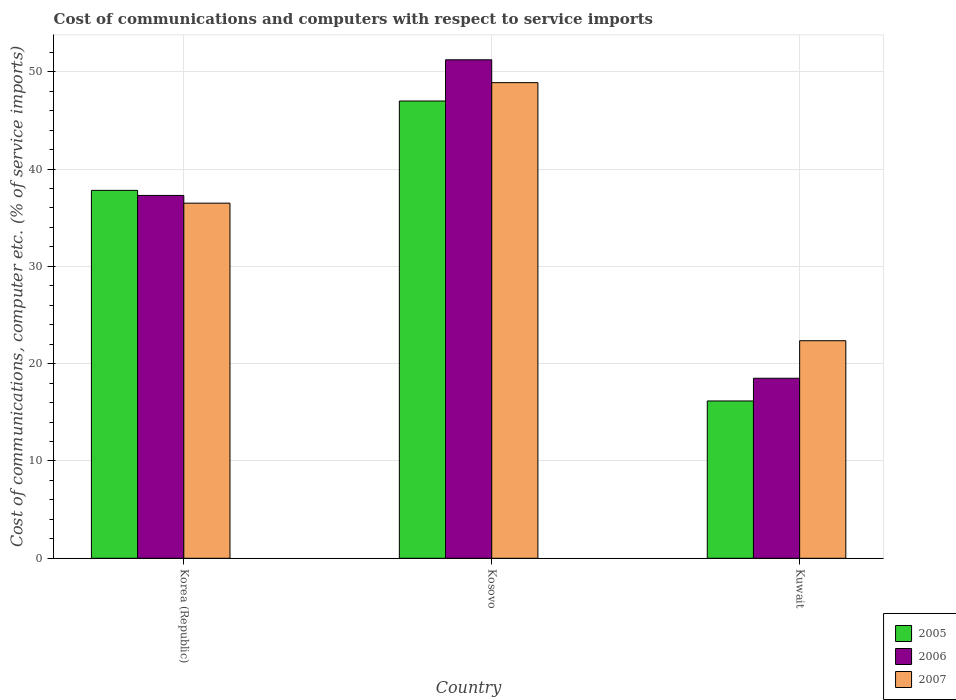How many groups of bars are there?
Ensure brevity in your answer.  3. Are the number of bars per tick equal to the number of legend labels?
Your response must be concise. Yes. How many bars are there on the 2nd tick from the right?
Your answer should be very brief. 3. What is the label of the 2nd group of bars from the left?
Provide a short and direct response. Kosovo. What is the cost of communications and computers in 2006 in Kuwait?
Provide a succinct answer. 18.5. Across all countries, what is the maximum cost of communications and computers in 2005?
Provide a succinct answer. 46.99. Across all countries, what is the minimum cost of communications and computers in 2007?
Make the answer very short. 22.36. In which country was the cost of communications and computers in 2005 maximum?
Give a very brief answer. Kosovo. In which country was the cost of communications and computers in 2006 minimum?
Offer a terse response. Kuwait. What is the total cost of communications and computers in 2005 in the graph?
Offer a terse response. 100.97. What is the difference between the cost of communications and computers in 2007 in Kosovo and that in Kuwait?
Your response must be concise. 26.52. What is the difference between the cost of communications and computers in 2007 in Kuwait and the cost of communications and computers in 2006 in Korea (Republic)?
Your response must be concise. -14.93. What is the average cost of communications and computers in 2006 per country?
Provide a succinct answer. 35.67. What is the difference between the cost of communications and computers of/in 2006 and cost of communications and computers of/in 2007 in Kuwait?
Offer a very short reply. -3.86. In how many countries, is the cost of communications and computers in 2006 greater than 24 %?
Your response must be concise. 2. What is the ratio of the cost of communications and computers in 2005 in Kosovo to that in Kuwait?
Give a very brief answer. 2.91. What is the difference between the highest and the second highest cost of communications and computers in 2005?
Offer a terse response. -21.64. What is the difference between the highest and the lowest cost of communications and computers in 2007?
Your answer should be compact. 26.52. In how many countries, is the cost of communications and computers in 2007 greater than the average cost of communications and computers in 2007 taken over all countries?
Your answer should be compact. 2. What does the 1st bar from the left in Kuwait represents?
Your answer should be very brief. 2005. What does the 3rd bar from the right in Kuwait represents?
Offer a terse response. 2005. Are all the bars in the graph horizontal?
Make the answer very short. No. How many countries are there in the graph?
Keep it short and to the point. 3. What is the difference between two consecutive major ticks on the Y-axis?
Keep it short and to the point. 10. Does the graph contain grids?
Make the answer very short. Yes. Where does the legend appear in the graph?
Make the answer very short. Bottom right. What is the title of the graph?
Provide a succinct answer. Cost of communications and computers with respect to service imports. What is the label or title of the X-axis?
Ensure brevity in your answer.  Country. What is the label or title of the Y-axis?
Offer a terse response. Cost of communications, computer etc. (% of service imports). What is the Cost of communications, computer etc. (% of service imports) in 2005 in Korea (Republic)?
Provide a short and direct response. 37.81. What is the Cost of communications, computer etc. (% of service imports) of 2006 in Korea (Republic)?
Your response must be concise. 37.29. What is the Cost of communications, computer etc. (% of service imports) of 2007 in Korea (Republic)?
Ensure brevity in your answer.  36.49. What is the Cost of communications, computer etc. (% of service imports) in 2005 in Kosovo?
Keep it short and to the point. 46.99. What is the Cost of communications, computer etc. (% of service imports) of 2006 in Kosovo?
Your answer should be compact. 51.23. What is the Cost of communications, computer etc. (% of service imports) in 2007 in Kosovo?
Offer a very short reply. 48.88. What is the Cost of communications, computer etc. (% of service imports) of 2005 in Kuwait?
Offer a terse response. 16.17. What is the Cost of communications, computer etc. (% of service imports) of 2006 in Kuwait?
Ensure brevity in your answer.  18.5. What is the Cost of communications, computer etc. (% of service imports) of 2007 in Kuwait?
Your answer should be compact. 22.36. Across all countries, what is the maximum Cost of communications, computer etc. (% of service imports) in 2005?
Make the answer very short. 46.99. Across all countries, what is the maximum Cost of communications, computer etc. (% of service imports) in 2006?
Provide a short and direct response. 51.23. Across all countries, what is the maximum Cost of communications, computer etc. (% of service imports) in 2007?
Offer a terse response. 48.88. Across all countries, what is the minimum Cost of communications, computer etc. (% of service imports) of 2005?
Give a very brief answer. 16.17. Across all countries, what is the minimum Cost of communications, computer etc. (% of service imports) of 2006?
Give a very brief answer. 18.5. Across all countries, what is the minimum Cost of communications, computer etc. (% of service imports) of 2007?
Provide a succinct answer. 22.36. What is the total Cost of communications, computer etc. (% of service imports) of 2005 in the graph?
Keep it short and to the point. 100.97. What is the total Cost of communications, computer etc. (% of service imports) of 2006 in the graph?
Keep it short and to the point. 107.02. What is the total Cost of communications, computer etc. (% of service imports) of 2007 in the graph?
Provide a succinct answer. 107.73. What is the difference between the Cost of communications, computer etc. (% of service imports) in 2005 in Korea (Republic) and that in Kosovo?
Your answer should be very brief. -9.18. What is the difference between the Cost of communications, computer etc. (% of service imports) of 2006 in Korea (Republic) and that in Kosovo?
Your answer should be very brief. -13.94. What is the difference between the Cost of communications, computer etc. (% of service imports) of 2007 in Korea (Republic) and that in Kosovo?
Make the answer very short. -12.39. What is the difference between the Cost of communications, computer etc. (% of service imports) of 2005 in Korea (Republic) and that in Kuwait?
Your answer should be compact. 21.64. What is the difference between the Cost of communications, computer etc. (% of service imports) in 2006 in Korea (Republic) and that in Kuwait?
Provide a short and direct response. 18.79. What is the difference between the Cost of communications, computer etc. (% of service imports) of 2007 in Korea (Republic) and that in Kuwait?
Your answer should be very brief. 14.14. What is the difference between the Cost of communications, computer etc. (% of service imports) of 2005 in Kosovo and that in Kuwait?
Give a very brief answer. 30.82. What is the difference between the Cost of communications, computer etc. (% of service imports) in 2006 in Kosovo and that in Kuwait?
Keep it short and to the point. 32.73. What is the difference between the Cost of communications, computer etc. (% of service imports) of 2007 in Kosovo and that in Kuwait?
Your answer should be very brief. 26.52. What is the difference between the Cost of communications, computer etc. (% of service imports) in 2005 in Korea (Republic) and the Cost of communications, computer etc. (% of service imports) in 2006 in Kosovo?
Offer a terse response. -13.42. What is the difference between the Cost of communications, computer etc. (% of service imports) in 2005 in Korea (Republic) and the Cost of communications, computer etc. (% of service imports) in 2007 in Kosovo?
Ensure brevity in your answer.  -11.07. What is the difference between the Cost of communications, computer etc. (% of service imports) in 2006 in Korea (Republic) and the Cost of communications, computer etc. (% of service imports) in 2007 in Kosovo?
Your response must be concise. -11.59. What is the difference between the Cost of communications, computer etc. (% of service imports) in 2005 in Korea (Republic) and the Cost of communications, computer etc. (% of service imports) in 2006 in Kuwait?
Offer a very short reply. 19.31. What is the difference between the Cost of communications, computer etc. (% of service imports) in 2005 in Korea (Republic) and the Cost of communications, computer etc. (% of service imports) in 2007 in Kuwait?
Give a very brief answer. 15.45. What is the difference between the Cost of communications, computer etc. (% of service imports) of 2006 in Korea (Republic) and the Cost of communications, computer etc. (% of service imports) of 2007 in Kuwait?
Offer a very short reply. 14.93. What is the difference between the Cost of communications, computer etc. (% of service imports) in 2005 in Kosovo and the Cost of communications, computer etc. (% of service imports) in 2006 in Kuwait?
Your answer should be very brief. 28.49. What is the difference between the Cost of communications, computer etc. (% of service imports) in 2005 in Kosovo and the Cost of communications, computer etc. (% of service imports) in 2007 in Kuwait?
Your answer should be very brief. 24.63. What is the difference between the Cost of communications, computer etc. (% of service imports) in 2006 in Kosovo and the Cost of communications, computer etc. (% of service imports) in 2007 in Kuwait?
Give a very brief answer. 28.87. What is the average Cost of communications, computer etc. (% of service imports) in 2005 per country?
Your answer should be very brief. 33.66. What is the average Cost of communications, computer etc. (% of service imports) of 2006 per country?
Ensure brevity in your answer.  35.67. What is the average Cost of communications, computer etc. (% of service imports) in 2007 per country?
Ensure brevity in your answer.  35.91. What is the difference between the Cost of communications, computer etc. (% of service imports) in 2005 and Cost of communications, computer etc. (% of service imports) in 2006 in Korea (Republic)?
Offer a very short reply. 0.52. What is the difference between the Cost of communications, computer etc. (% of service imports) in 2005 and Cost of communications, computer etc. (% of service imports) in 2007 in Korea (Republic)?
Your response must be concise. 1.32. What is the difference between the Cost of communications, computer etc. (% of service imports) in 2006 and Cost of communications, computer etc. (% of service imports) in 2007 in Korea (Republic)?
Ensure brevity in your answer.  0.8. What is the difference between the Cost of communications, computer etc. (% of service imports) of 2005 and Cost of communications, computer etc. (% of service imports) of 2006 in Kosovo?
Offer a very short reply. -4.24. What is the difference between the Cost of communications, computer etc. (% of service imports) in 2005 and Cost of communications, computer etc. (% of service imports) in 2007 in Kosovo?
Provide a short and direct response. -1.89. What is the difference between the Cost of communications, computer etc. (% of service imports) of 2006 and Cost of communications, computer etc. (% of service imports) of 2007 in Kosovo?
Your answer should be very brief. 2.35. What is the difference between the Cost of communications, computer etc. (% of service imports) in 2005 and Cost of communications, computer etc. (% of service imports) in 2006 in Kuwait?
Keep it short and to the point. -2.33. What is the difference between the Cost of communications, computer etc. (% of service imports) in 2005 and Cost of communications, computer etc. (% of service imports) in 2007 in Kuwait?
Offer a very short reply. -6.19. What is the difference between the Cost of communications, computer etc. (% of service imports) of 2006 and Cost of communications, computer etc. (% of service imports) of 2007 in Kuwait?
Make the answer very short. -3.86. What is the ratio of the Cost of communications, computer etc. (% of service imports) of 2005 in Korea (Republic) to that in Kosovo?
Keep it short and to the point. 0.8. What is the ratio of the Cost of communications, computer etc. (% of service imports) of 2006 in Korea (Republic) to that in Kosovo?
Your answer should be very brief. 0.73. What is the ratio of the Cost of communications, computer etc. (% of service imports) in 2007 in Korea (Republic) to that in Kosovo?
Provide a short and direct response. 0.75. What is the ratio of the Cost of communications, computer etc. (% of service imports) in 2005 in Korea (Republic) to that in Kuwait?
Keep it short and to the point. 2.34. What is the ratio of the Cost of communications, computer etc. (% of service imports) of 2006 in Korea (Republic) to that in Kuwait?
Provide a succinct answer. 2.02. What is the ratio of the Cost of communications, computer etc. (% of service imports) in 2007 in Korea (Republic) to that in Kuwait?
Your answer should be very brief. 1.63. What is the ratio of the Cost of communications, computer etc. (% of service imports) of 2005 in Kosovo to that in Kuwait?
Offer a very short reply. 2.91. What is the ratio of the Cost of communications, computer etc. (% of service imports) of 2006 in Kosovo to that in Kuwait?
Offer a very short reply. 2.77. What is the ratio of the Cost of communications, computer etc. (% of service imports) in 2007 in Kosovo to that in Kuwait?
Offer a terse response. 2.19. What is the difference between the highest and the second highest Cost of communications, computer etc. (% of service imports) of 2005?
Ensure brevity in your answer.  9.18. What is the difference between the highest and the second highest Cost of communications, computer etc. (% of service imports) of 2006?
Your answer should be compact. 13.94. What is the difference between the highest and the second highest Cost of communications, computer etc. (% of service imports) in 2007?
Give a very brief answer. 12.39. What is the difference between the highest and the lowest Cost of communications, computer etc. (% of service imports) in 2005?
Make the answer very short. 30.82. What is the difference between the highest and the lowest Cost of communications, computer etc. (% of service imports) in 2006?
Keep it short and to the point. 32.73. What is the difference between the highest and the lowest Cost of communications, computer etc. (% of service imports) of 2007?
Your response must be concise. 26.52. 